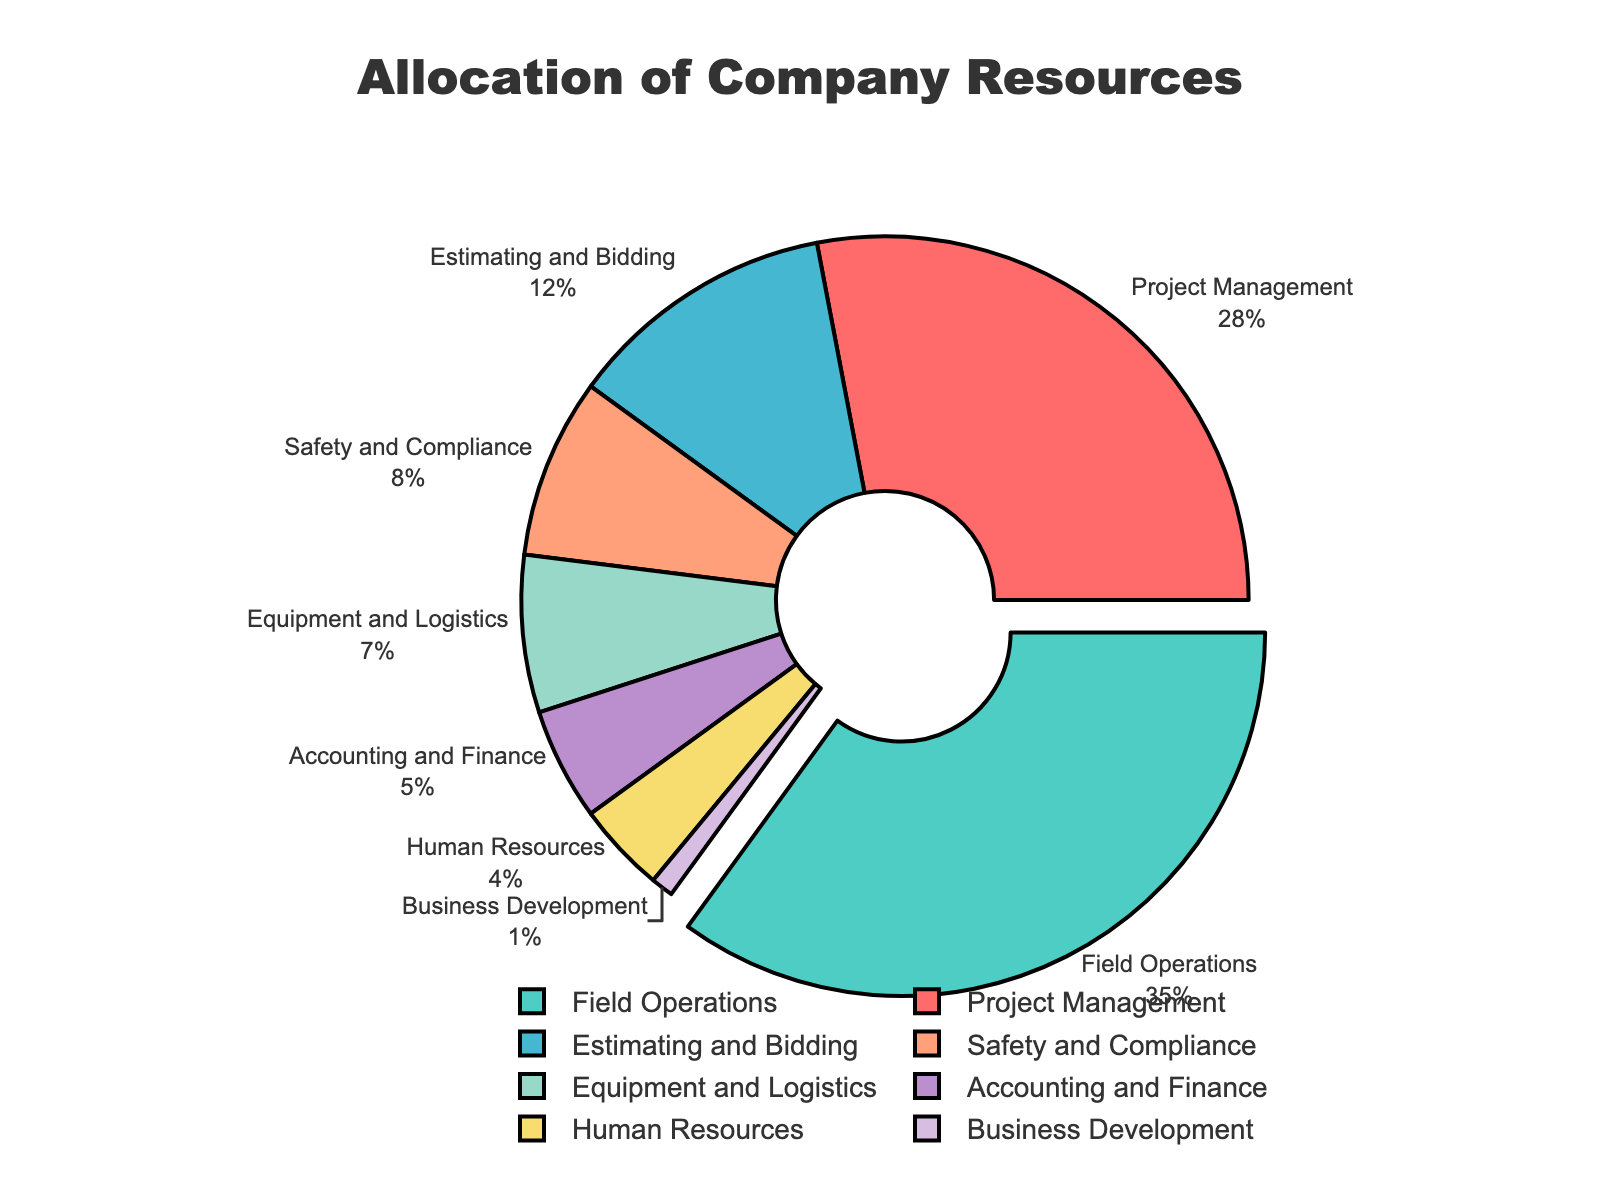What's the percentage allocated to the largest department? The largest department is the one with the highest allocation percentage. From the pie chart, it's clear that Field Operations has the largest allocation.
Answer: 35% What is the sum of the allocations for Equipment and Logistics and Accounting and Finance? According to the pie chart, Equipment and Logistics is allocated 7% and Accounting and Finance is allocated 5%. Adding these together, 7% + 5% = 12%.
Answer: 12% Which department has a higher allocation: Safety and Compliance or Human Resources? Referring to the pie chart, Safety and Compliance is allocated 8%, while Human Resources is allocated 4%. Therefore, Safety and Compliance has a higher allocation.
Answer: Safety and Compliance By how much is the allocation for Project Management greater than that for Estimating and Bidding? The allocation for Project Management is 28%, and for Estimating and Bidding, it is 12%. The difference is 28% - 12% = 16%.
Answer: 16% Which department has the smallest allocation and what is its percentage? From the pie chart, Business Development has the smallest allocation. The percentage allocated to Business Development is 1%.
Answer: Business Development, 1% If the allocations for Safety and Compliance, Equipment and Logistics, and Business Development are combined, what percentage will they make up? Adding the percentages for Safety and Compliance (8%), Equipment and Logistics (7%), and Business Development (1%) gives 8% + 7% + 1% = 16%.
Answer: 16% What is the average allocation percentage for Human Resources, Accounting and Finance, and Business Development? The allocations are Human Resources (4%), Accounting and Finance (5%), and Business Development (1%). The average is calculated as (4% + 5% + 1%) / 3 = 10% / 3 ≈ 3.33%.
Answer: 3.33% How does the allocation for Project Management compare to the total allocation for Safety and Compliance and Human Resources combined? The allocation for Project Management is 28%. The combined allocation for Safety and Compliance (8%) and Human Resources (4%) is 8% + 4% = 12%. Comparing these, 28% is more than 12%.
Answer: Project Management > Safety and Compliance + Human Resources 